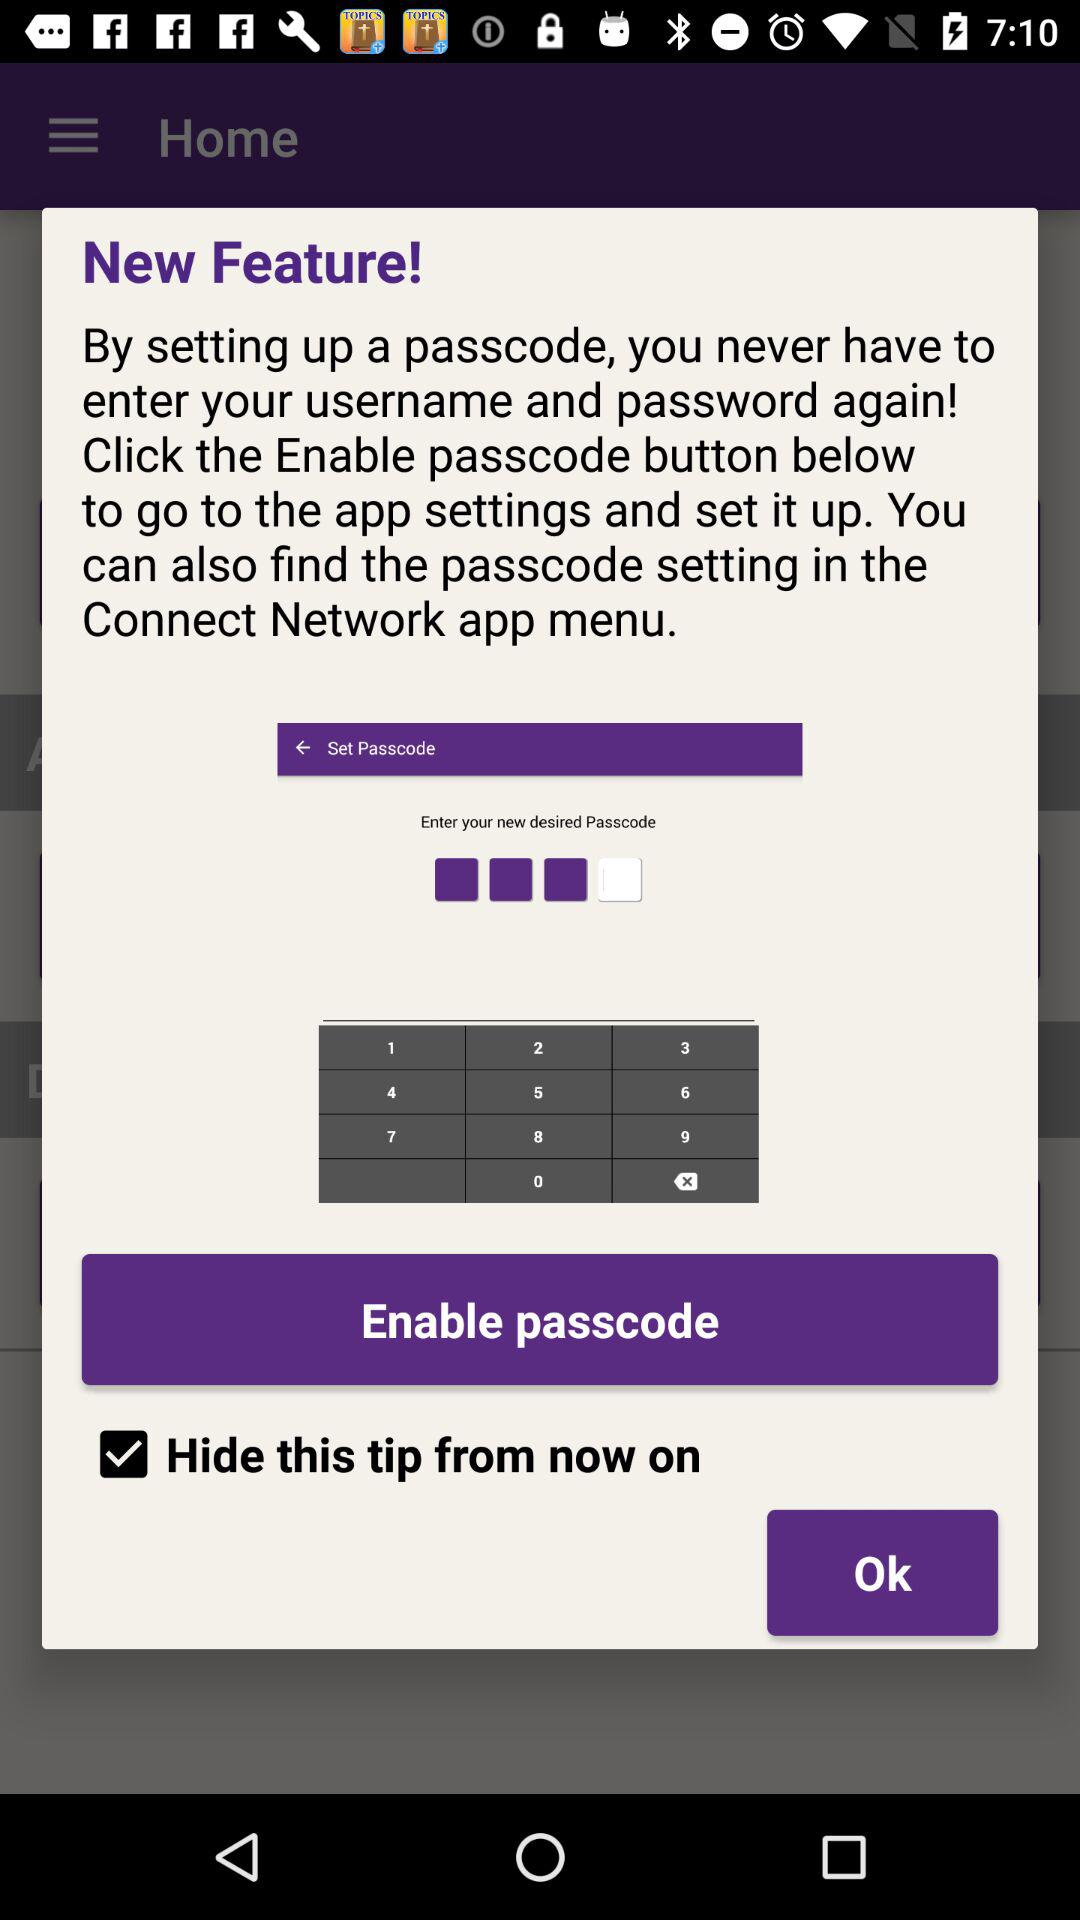What is the status of "Hide this tip from now on"? The status of "Hide this tip from now on" is "on". 